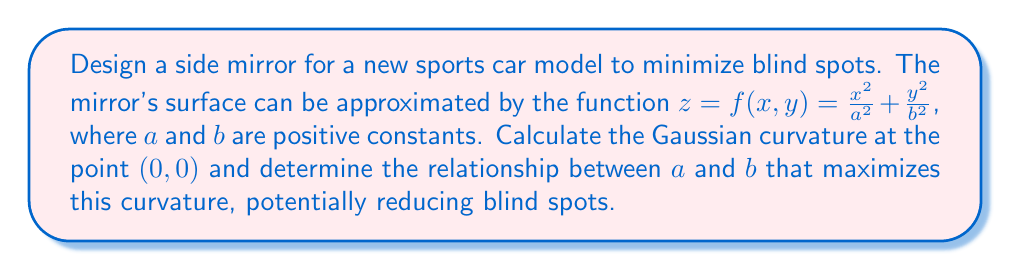Solve this math problem. 1) The Gaussian curvature $K$ is given by:

   $$K = \frac{f_{xx}f_{yy} - f_{xy}^2}{(1 + f_x^2 + f_y^2)^2}$$

   where subscripts denote partial derivatives.

2) Calculate the partial derivatives:
   $$f_x = \frac{2x}{a^2}, \quad f_y = \frac{2y}{b^2}$$
   $$f_{xx} = \frac{2}{a^2}, \quad f_{yy} = \frac{2}{b^2}, \quad f_{xy} = 0$$

3) At point $(0,0)$:
   $f_x = f_y = 0$
   $f_{xx} = \frac{2}{a^2}, \quad f_{yy} = \frac{2}{b^2}, \quad f_{xy} = 0$

4) Substitute into the Gaussian curvature formula:

   $$K_{(0,0)} = \frac{\frac{2}{a^2} \cdot \frac{2}{b^2} - 0^2}{(1 + 0^2 + 0^2)^2} = \frac{4}{a^2b^2}$$

5) To maximize $K_{(0,0)}$, we need to minimize $a^2b^2$.

6) Given the constraint that $a$ and $b$ are positive constants, the product $a^2b^2$ is minimized when $a = b$.

Therefore, the Gaussian curvature at $(0,0)$ is maximized when $a = b$, resulting in a circular cross-section of the mirror.
Answer: $K_{(0,0)} = \frac{4}{a^2b^2}$; maximized when $a = b$ 